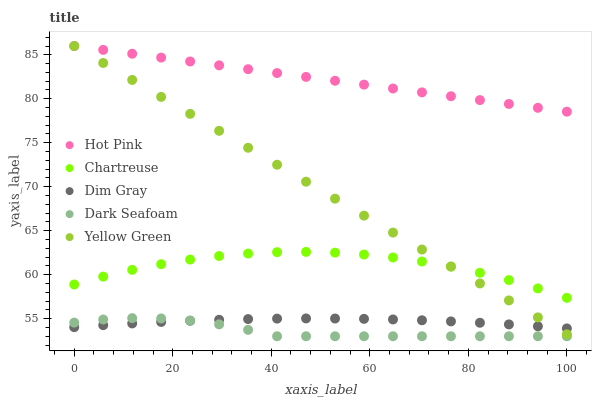Does Dark Seafoam have the minimum area under the curve?
Answer yes or no. Yes. Does Hot Pink have the maximum area under the curve?
Answer yes or no. Yes. Does Hot Pink have the minimum area under the curve?
Answer yes or no. No. Does Dark Seafoam have the maximum area under the curve?
Answer yes or no. No. Is Hot Pink the smoothest?
Answer yes or no. Yes. Is Chartreuse the roughest?
Answer yes or no. Yes. Is Dark Seafoam the smoothest?
Answer yes or no. No. Is Dark Seafoam the roughest?
Answer yes or no. No. Does Dark Seafoam have the lowest value?
Answer yes or no. Yes. Does Hot Pink have the lowest value?
Answer yes or no. No. Does Yellow Green have the highest value?
Answer yes or no. Yes. Does Dark Seafoam have the highest value?
Answer yes or no. No. Is Dark Seafoam less than Yellow Green?
Answer yes or no. Yes. Is Yellow Green greater than Dark Seafoam?
Answer yes or no. Yes. Does Hot Pink intersect Yellow Green?
Answer yes or no. Yes. Is Hot Pink less than Yellow Green?
Answer yes or no. No. Is Hot Pink greater than Yellow Green?
Answer yes or no. No. Does Dark Seafoam intersect Yellow Green?
Answer yes or no. No. 